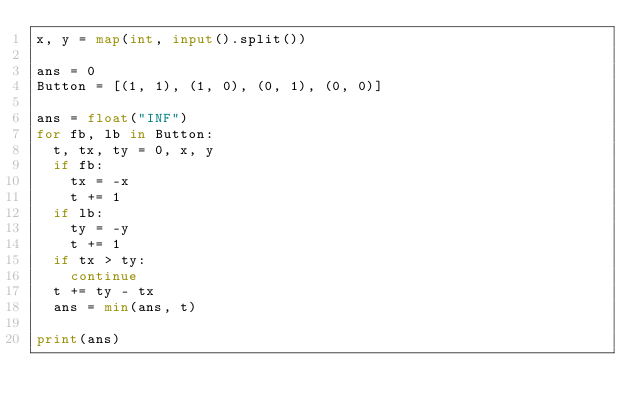<code> <loc_0><loc_0><loc_500><loc_500><_Python_>x, y = map(int, input().split())

ans = 0
Button = [(1, 1), (1, 0), (0, 1), (0, 0)]

ans = float("INF")
for fb, lb in Button:
  t, tx, ty = 0, x, y
  if fb:
    tx = -x
    t += 1
  if lb:
    ty = -y
    t += 1
  if tx > ty:
    continue
  t += ty - tx
  ans = min(ans, t)

print(ans)</code> 